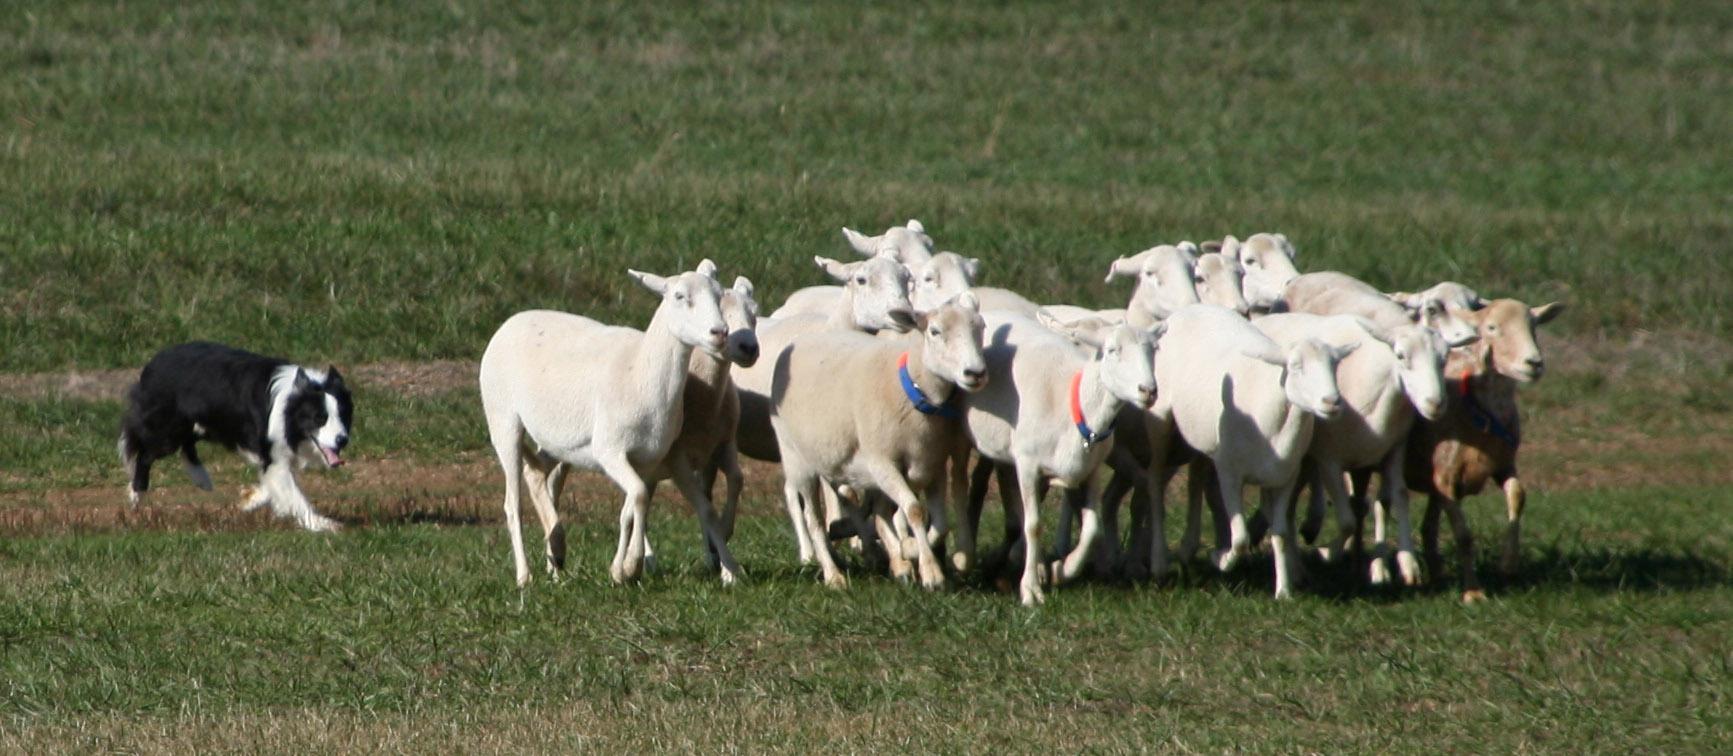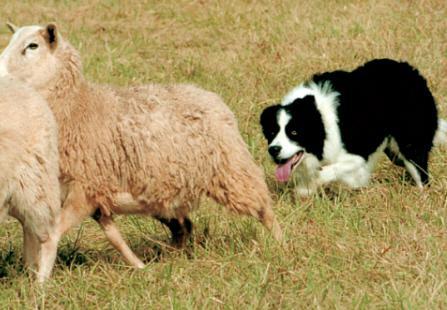The first image is the image on the left, the second image is the image on the right. Evaluate the accuracy of this statement regarding the images: "An image shows a dog at the right herding no more than three sheep, which are at the left.". Is it true? Answer yes or no. Yes. 